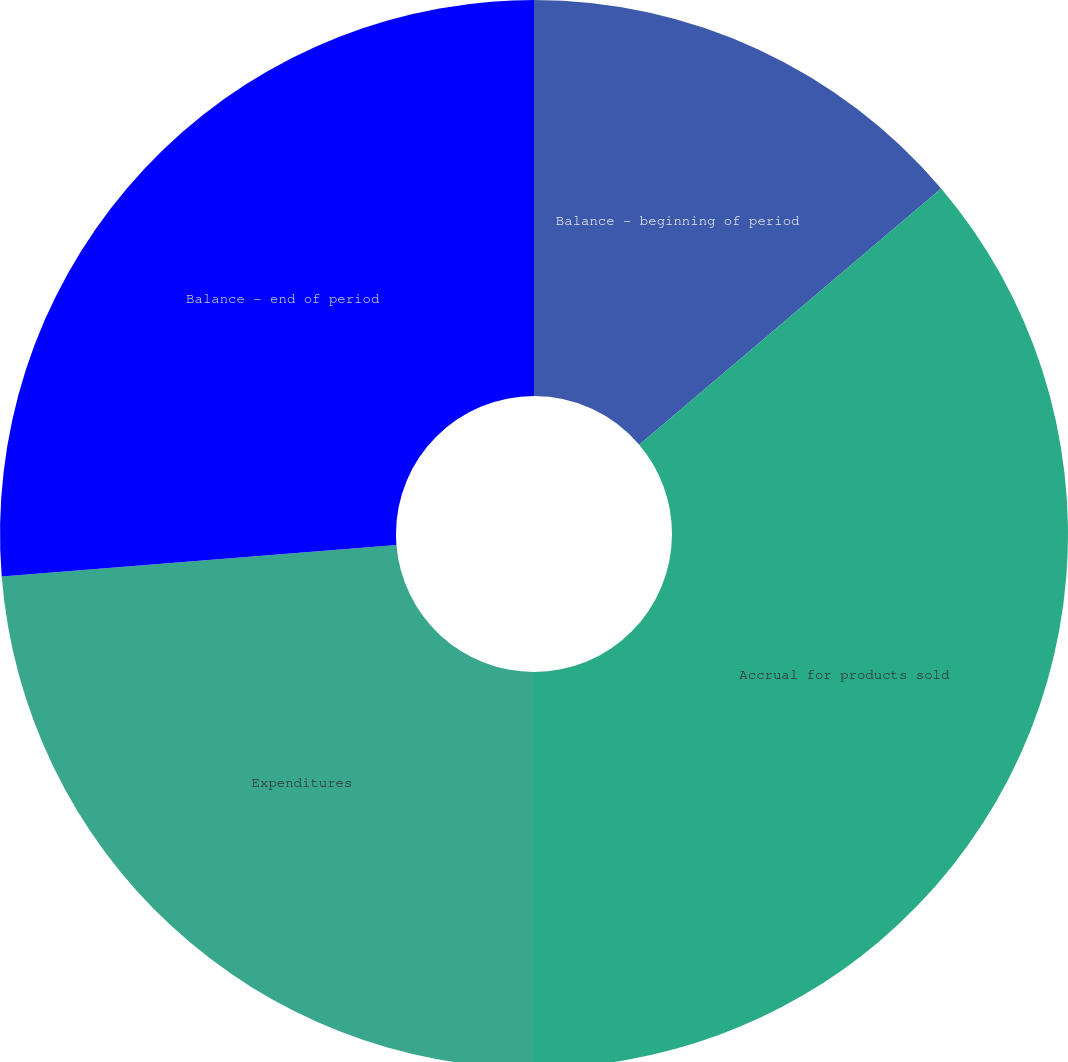Convert chart. <chart><loc_0><loc_0><loc_500><loc_500><pie_chart><fcel>Balance - beginning of period<fcel>Accrual for products sold<fcel>Expenditures<fcel>Balance - end of period<nl><fcel>13.8%<fcel>36.2%<fcel>23.73%<fcel>26.27%<nl></chart> 